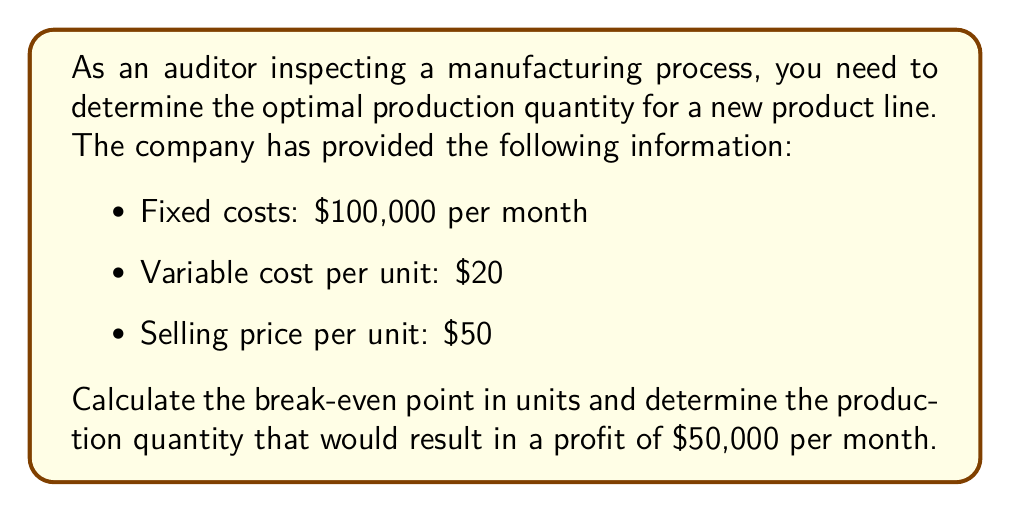What is the answer to this math problem? To solve this problem, we'll use the break-even analysis formula and then extend it to find the production quantity for the desired profit.

Step 1: Calculate the break-even point in units

The break-even point is where total revenue equals total costs.

Let $x$ be the number of units produced and sold.

Total Revenue = Selling price per unit × Number of units
$TR = 50x$

Total Costs = Fixed costs + (Variable cost per unit × Number of units)
$TC = 100,000 + 20x$

At break-even point: $TR = TC$

$$50x = 100,000 + 20x$$
$$30x = 100,000$$
$$x = \frac{100,000}{30} = 3,333.33$$

Since we can't produce a fractional unit, we round up to 3,334 units.

Step 2: Calculate the production quantity for $50,000 profit

To find this, we set up the equation:
Total Revenue - Total Costs = Desired Profit

$$50x - (100,000 + 20x) = 50,000$$
$$50x - 100,000 - 20x = 50,000$$
$$30x = 200,000$$
$$x = \frac{200,000}{30} = 6,666.67$$

Rounding up, we get 6,667 units.
Answer: Break-even point: 3,334 units; Quantity for $50,000 profit: 6,667 units 